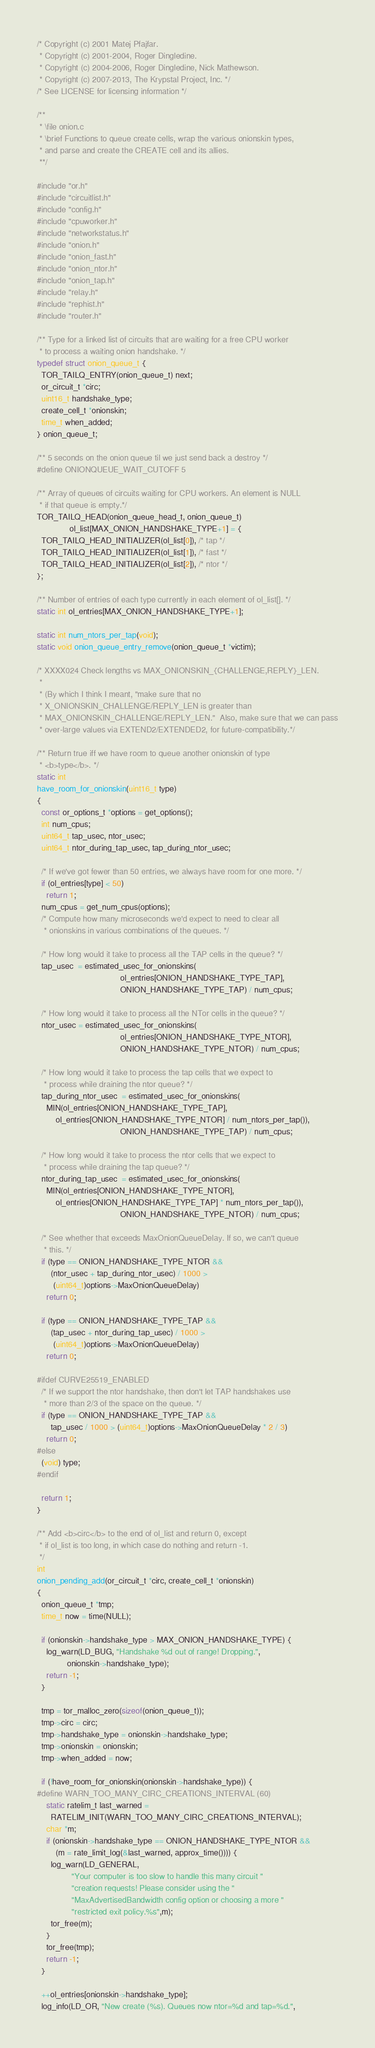Convert code to text. <code><loc_0><loc_0><loc_500><loc_500><_C_>/* Copyright (c) 2001 Matej Pfajfar.
 * Copyright (c) 2001-2004, Roger Dingledine.
 * Copyright (c) 2004-2006, Roger Dingledine, Nick Mathewson.
 * Copyright (c) 2007-2013, The Krypstal Project, Inc. */
/* See LICENSE for licensing information */

/**
 * \file onion.c
 * \brief Functions to queue create cells, wrap the various onionskin types,
 * and parse and create the CREATE cell and its allies.
 **/

#include "or.h"
#include "circuitlist.h"
#include "config.h"
#include "cpuworker.h"
#include "networkstatus.h"
#include "onion.h"
#include "onion_fast.h"
#include "onion_ntor.h"
#include "onion_tap.h"
#include "relay.h"
#include "rephist.h"
#include "router.h"

/** Type for a linked list of circuits that are waiting for a free CPU worker
 * to process a waiting onion handshake. */
typedef struct onion_queue_t {
  TOR_TAILQ_ENTRY(onion_queue_t) next;
  or_circuit_t *circ;
  uint16_t handshake_type;
  create_cell_t *onionskin;
  time_t when_added;
} onion_queue_t;

/** 5 seconds on the onion queue til we just send back a destroy */
#define ONIONQUEUE_WAIT_CUTOFF 5

/** Array of queues of circuits waiting for CPU workers. An element is NULL
 * if that queue is empty.*/
TOR_TAILQ_HEAD(onion_queue_head_t, onion_queue_t)
              ol_list[MAX_ONION_HANDSHAKE_TYPE+1] = {
  TOR_TAILQ_HEAD_INITIALIZER(ol_list[0]), /* tap */
  TOR_TAILQ_HEAD_INITIALIZER(ol_list[1]), /* fast */
  TOR_TAILQ_HEAD_INITIALIZER(ol_list[2]), /* ntor */
};

/** Number of entries of each type currently in each element of ol_list[]. */
static int ol_entries[MAX_ONION_HANDSHAKE_TYPE+1];

static int num_ntors_per_tap(void);
static void onion_queue_entry_remove(onion_queue_t *victim);

/* XXXX024 Check lengths vs MAX_ONIONSKIN_{CHALLENGE,REPLY}_LEN.
 *
 * (By which I think I meant, "make sure that no
 * X_ONIONSKIN_CHALLENGE/REPLY_LEN is greater than
 * MAX_ONIONSKIN_CHALLENGE/REPLY_LEN."  Also, make sure that we can pass
 * over-large values via EXTEND2/EXTENDED2, for future-compatibility.*/

/** Return true iff we have room to queue another onionskin of type
 * <b>type</b>. */
static int
have_room_for_onionskin(uint16_t type)
{
  const or_options_t *options = get_options();
  int num_cpus;
  uint64_t tap_usec, ntor_usec;
  uint64_t ntor_during_tap_usec, tap_during_ntor_usec;

  /* If we've got fewer than 50 entries, we always have room for one more. */
  if (ol_entries[type] < 50)
    return 1;
  num_cpus = get_num_cpus(options);
  /* Compute how many microseconds we'd expect to need to clear all
   * onionskins in various combinations of the queues. */

  /* How long would it take to process all the TAP cells in the queue? */
  tap_usec  = estimated_usec_for_onionskins(
                                    ol_entries[ONION_HANDSHAKE_TYPE_TAP],
                                    ONION_HANDSHAKE_TYPE_TAP) / num_cpus;

  /* How long would it take to process all the NTor cells in the queue? */
  ntor_usec = estimated_usec_for_onionskins(
                                    ol_entries[ONION_HANDSHAKE_TYPE_NTOR],
                                    ONION_HANDSHAKE_TYPE_NTOR) / num_cpus;

  /* How long would it take to process the tap cells that we expect to
   * process while draining the ntor queue? */
  tap_during_ntor_usec  = estimated_usec_for_onionskins(
    MIN(ol_entries[ONION_HANDSHAKE_TYPE_TAP],
        ol_entries[ONION_HANDSHAKE_TYPE_NTOR] / num_ntors_per_tap()),
                                    ONION_HANDSHAKE_TYPE_TAP) / num_cpus;

  /* How long would it take to process the ntor cells that we expect to
   * process while draining the tap queue? */
  ntor_during_tap_usec  = estimated_usec_for_onionskins(
    MIN(ol_entries[ONION_HANDSHAKE_TYPE_NTOR],
        ol_entries[ONION_HANDSHAKE_TYPE_TAP] * num_ntors_per_tap()),
                                    ONION_HANDSHAKE_TYPE_NTOR) / num_cpus;

  /* See whether that exceeds MaxOnionQueueDelay. If so, we can't queue
   * this. */
  if (type == ONION_HANDSHAKE_TYPE_NTOR &&
      (ntor_usec + tap_during_ntor_usec) / 1000 >
       (uint64_t)options->MaxOnionQueueDelay)
    return 0;

  if (type == ONION_HANDSHAKE_TYPE_TAP &&
      (tap_usec + ntor_during_tap_usec) / 1000 >
       (uint64_t)options->MaxOnionQueueDelay)
    return 0;

#ifdef CURVE25519_ENABLED
  /* If we support the ntor handshake, then don't let TAP handshakes use
   * more than 2/3 of the space on the queue. */
  if (type == ONION_HANDSHAKE_TYPE_TAP &&
      tap_usec / 1000 > (uint64_t)options->MaxOnionQueueDelay * 2 / 3)
    return 0;
#else
  (void) type;
#endif

  return 1;
}

/** Add <b>circ</b> to the end of ol_list and return 0, except
 * if ol_list is too long, in which case do nothing and return -1.
 */
int
onion_pending_add(or_circuit_t *circ, create_cell_t *onionskin)
{
  onion_queue_t *tmp;
  time_t now = time(NULL);

  if (onionskin->handshake_type > MAX_ONION_HANDSHAKE_TYPE) {
    log_warn(LD_BUG, "Handshake %d out of range! Dropping.",
             onionskin->handshake_type);
    return -1;
  }

  tmp = tor_malloc_zero(sizeof(onion_queue_t));
  tmp->circ = circ;
  tmp->handshake_type = onionskin->handshake_type;
  tmp->onionskin = onionskin;
  tmp->when_added = now;

  if (!have_room_for_onionskin(onionskin->handshake_type)) {
#define WARN_TOO_MANY_CIRC_CREATIONS_INTERVAL (60)
    static ratelim_t last_warned =
      RATELIM_INIT(WARN_TOO_MANY_CIRC_CREATIONS_INTERVAL);
    char *m;
    if (onionskin->handshake_type == ONION_HANDSHAKE_TYPE_NTOR &&
        (m = rate_limit_log(&last_warned, approx_time()))) {
      log_warn(LD_GENERAL,
               "Your computer is too slow to handle this many circuit "
               "creation requests! Please consider using the "
               "MaxAdvertisedBandwidth config option or choosing a more "
               "restricted exit policy.%s",m);
      tor_free(m);
    }
    tor_free(tmp);
    return -1;
  }

  ++ol_entries[onionskin->handshake_type];
  log_info(LD_OR, "New create (%s). Queues now ntor=%d and tap=%d.",</code> 